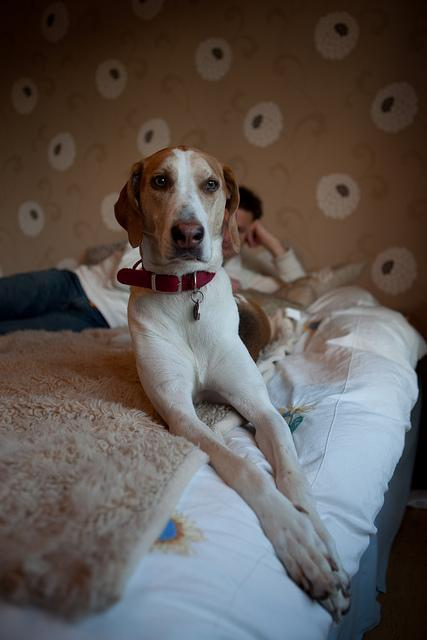What is the purpose of the item tied around his neck? Please explain your reasoning. identification. The dog collar is used to identify the dog. 